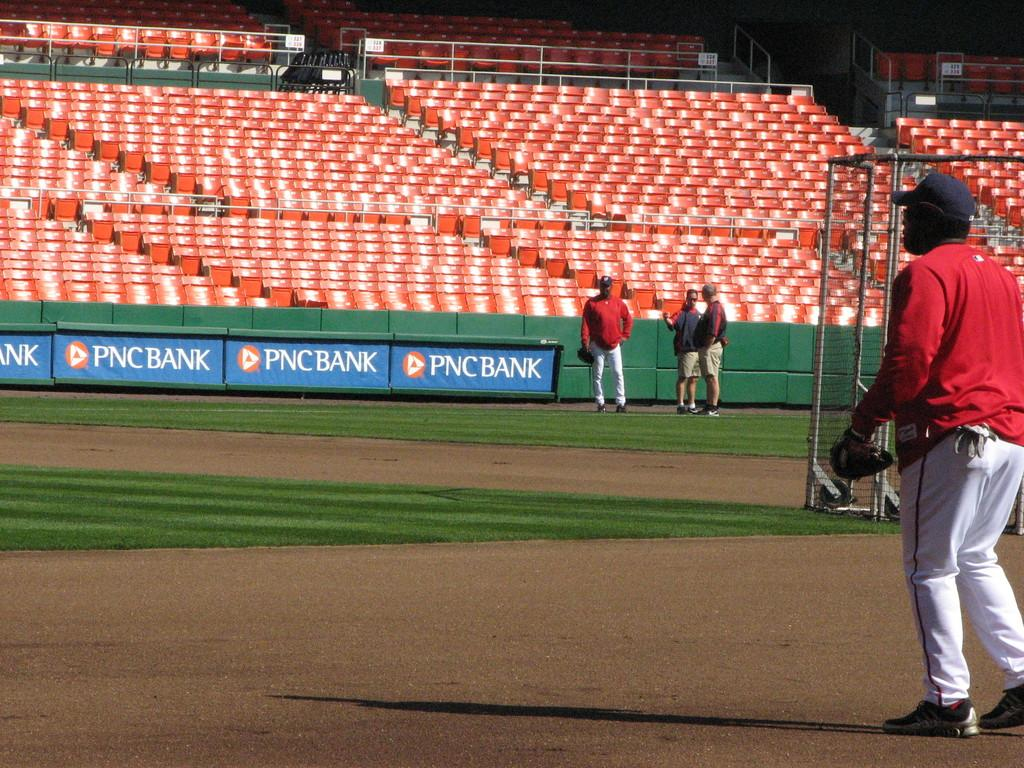How many people are standing on the path in the image? There are four people standing on the path in the image. What is located between the people? There is an item between the people. What type of furniture is visible behind the people? There are chairs behind the people. What type of fence is visible behind the people? There is a steel fence behind the people. What type of mint is being used by the woman in the image? There is no woman present in the image, nor is there any mint. 